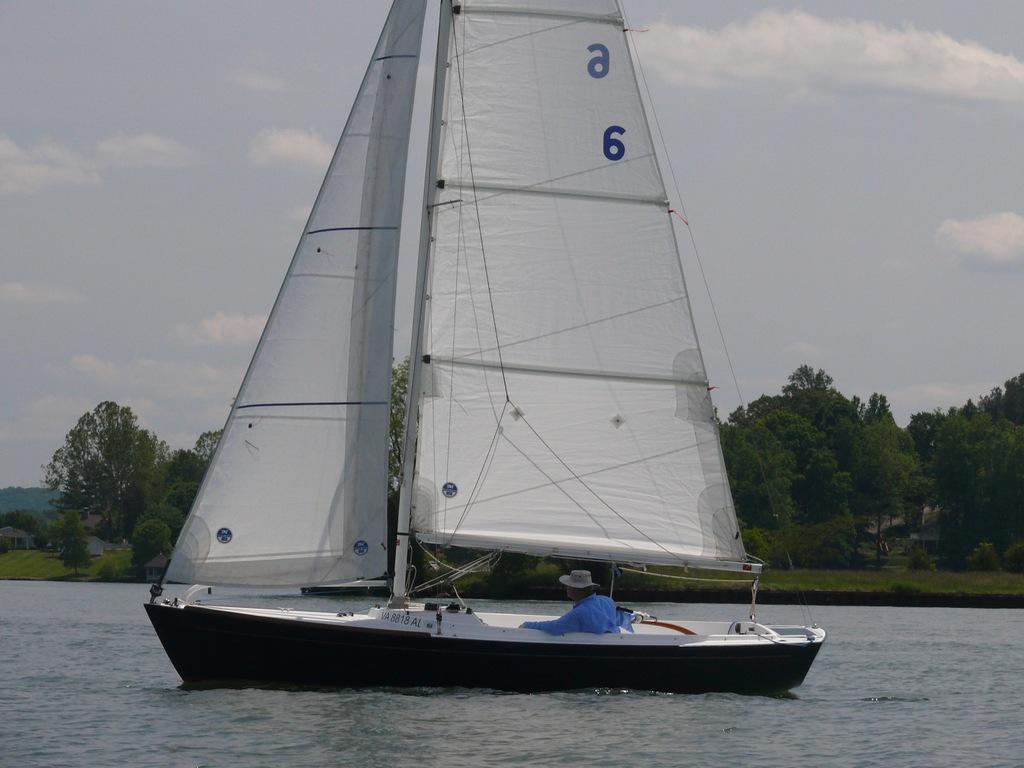<image>
Describe the image concisely. A boat with the number VA 8818 AL sails on a lake. 